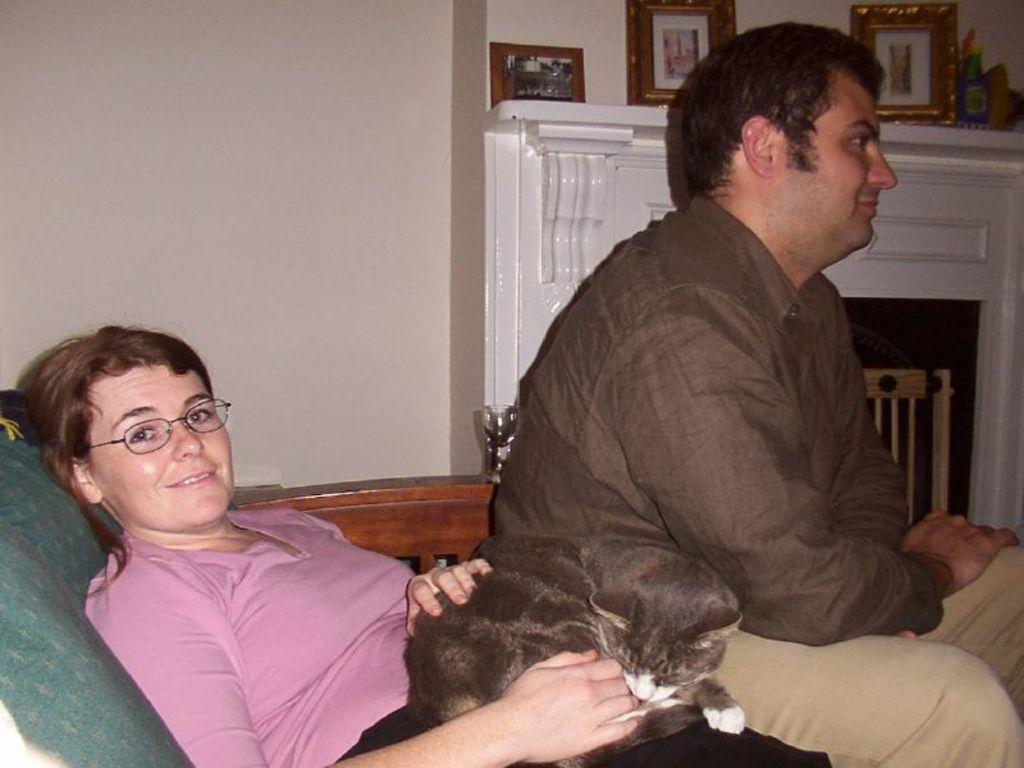How many people are in the image? There are two people in the image, a man and a woman. What are the man and woman doing in the image? The man and woman are sitting on a chair. What is the woman doing specifically? The woman is catching a cat. What type of grape is the man holding in the image? There is no grape present in the image; the man and woman are sitting on a chair and the woman is catching a cat. What kind of building can be seen in the background of the image? There is no building visible in the image; the focus is on the man, woman, and cat. 